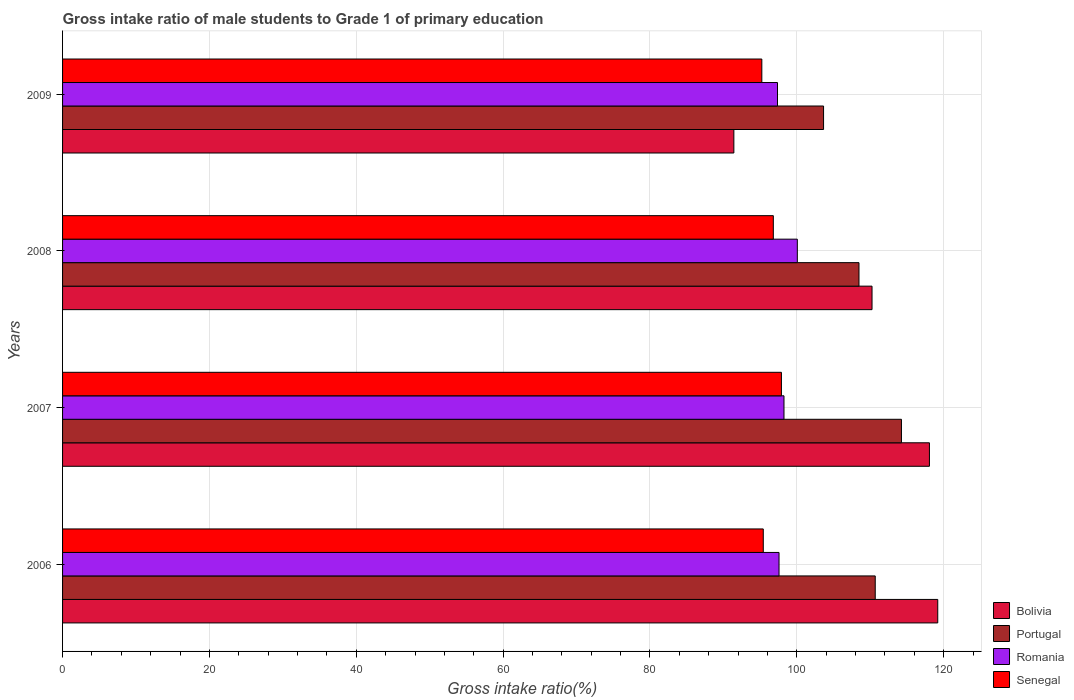How many bars are there on the 3rd tick from the top?
Your answer should be very brief. 4. What is the label of the 3rd group of bars from the top?
Offer a very short reply. 2007. In how many cases, is the number of bars for a given year not equal to the number of legend labels?
Provide a succinct answer. 0. What is the gross intake ratio in Romania in 2009?
Make the answer very short. 97.37. Across all years, what is the maximum gross intake ratio in Senegal?
Your answer should be compact. 97.9. Across all years, what is the minimum gross intake ratio in Portugal?
Keep it short and to the point. 103.64. In which year was the gross intake ratio in Portugal maximum?
Keep it short and to the point. 2007. What is the total gross intake ratio in Portugal in the graph?
Provide a succinct answer. 437.03. What is the difference between the gross intake ratio in Portugal in 2006 and that in 2007?
Offer a terse response. -3.57. What is the difference between the gross intake ratio in Romania in 2006 and the gross intake ratio in Portugal in 2007?
Your answer should be compact. -16.67. What is the average gross intake ratio in Senegal per year?
Keep it short and to the point. 96.34. In the year 2006, what is the difference between the gross intake ratio in Romania and gross intake ratio in Bolivia?
Provide a short and direct response. -21.62. In how many years, is the gross intake ratio in Portugal greater than 104 %?
Ensure brevity in your answer.  3. What is the ratio of the gross intake ratio in Bolivia in 2006 to that in 2009?
Offer a terse response. 1.3. What is the difference between the highest and the second highest gross intake ratio in Senegal?
Offer a terse response. 1.1. What is the difference between the highest and the lowest gross intake ratio in Portugal?
Offer a terse response. 10.61. What does the 3rd bar from the top in 2008 represents?
Give a very brief answer. Portugal. What does the 1st bar from the bottom in 2009 represents?
Ensure brevity in your answer.  Bolivia. Is it the case that in every year, the sum of the gross intake ratio in Romania and gross intake ratio in Senegal is greater than the gross intake ratio in Bolivia?
Offer a very short reply. Yes. Are the values on the major ticks of X-axis written in scientific E-notation?
Your answer should be compact. No. Does the graph contain grids?
Offer a very short reply. Yes. Where does the legend appear in the graph?
Ensure brevity in your answer.  Bottom right. How are the legend labels stacked?
Offer a very short reply. Vertical. What is the title of the graph?
Provide a succinct answer. Gross intake ratio of male students to Grade 1 of primary education. What is the label or title of the X-axis?
Make the answer very short. Gross intake ratio(%). What is the label or title of the Y-axis?
Make the answer very short. Years. What is the Gross intake ratio(%) of Bolivia in 2006?
Your answer should be very brief. 119.19. What is the Gross intake ratio(%) of Portugal in 2006?
Make the answer very short. 110.68. What is the Gross intake ratio(%) in Romania in 2006?
Provide a short and direct response. 97.58. What is the Gross intake ratio(%) of Senegal in 2006?
Your answer should be very brief. 95.43. What is the Gross intake ratio(%) of Bolivia in 2007?
Offer a terse response. 118.06. What is the Gross intake ratio(%) of Portugal in 2007?
Provide a short and direct response. 114.25. What is the Gross intake ratio(%) of Romania in 2007?
Keep it short and to the point. 98.25. What is the Gross intake ratio(%) in Senegal in 2007?
Ensure brevity in your answer.  97.9. What is the Gross intake ratio(%) of Bolivia in 2008?
Your answer should be compact. 110.24. What is the Gross intake ratio(%) of Portugal in 2008?
Your answer should be compact. 108.47. What is the Gross intake ratio(%) of Romania in 2008?
Ensure brevity in your answer.  100.07. What is the Gross intake ratio(%) in Senegal in 2008?
Keep it short and to the point. 96.8. What is the Gross intake ratio(%) of Bolivia in 2009?
Your answer should be very brief. 91.42. What is the Gross intake ratio(%) in Portugal in 2009?
Provide a succinct answer. 103.64. What is the Gross intake ratio(%) in Romania in 2009?
Keep it short and to the point. 97.37. What is the Gross intake ratio(%) of Senegal in 2009?
Offer a terse response. 95.23. Across all years, what is the maximum Gross intake ratio(%) of Bolivia?
Your answer should be compact. 119.19. Across all years, what is the maximum Gross intake ratio(%) of Portugal?
Make the answer very short. 114.25. Across all years, what is the maximum Gross intake ratio(%) in Romania?
Your answer should be very brief. 100.07. Across all years, what is the maximum Gross intake ratio(%) in Senegal?
Keep it short and to the point. 97.9. Across all years, what is the minimum Gross intake ratio(%) in Bolivia?
Offer a very short reply. 91.42. Across all years, what is the minimum Gross intake ratio(%) of Portugal?
Provide a short and direct response. 103.64. Across all years, what is the minimum Gross intake ratio(%) of Romania?
Keep it short and to the point. 97.37. Across all years, what is the minimum Gross intake ratio(%) in Senegal?
Your answer should be very brief. 95.23. What is the total Gross intake ratio(%) of Bolivia in the graph?
Your answer should be compact. 438.91. What is the total Gross intake ratio(%) of Portugal in the graph?
Your response must be concise. 437.03. What is the total Gross intake ratio(%) of Romania in the graph?
Offer a terse response. 393.26. What is the total Gross intake ratio(%) of Senegal in the graph?
Offer a terse response. 385.36. What is the difference between the Gross intake ratio(%) in Bolivia in 2006 and that in 2007?
Give a very brief answer. 1.13. What is the difference between the Gross intake ratio(%) of Portugal in 2006 and that in 2007?
Keep it short and to the point. -3.57. What is the difference between the Gross intake ratio(%) of Romania in 2006 and that in 2007?
Make the answer very short. -0.67. What is the difference between the Gross intake ratio(%) in Senegal in 2006 and that in 2007?
Make the answer very short. -2.47. What is the difference between the Gross intake ratio(%) of Bolivia in 2006 and that in 2008?
Keep it short and to the point. 8.95. What is the difference between the Gross intake ratio(%) in Portugal in 2006 and that in 2008?
Ensure brevity in your answer.  2.21. What is the difference between the Gross intake ratio(%) of Romania in 2006 and that in 2008?
Your answer should be very brief. -2.49. What is the difference between the Gross intake ratio(%) of Senegal in 2006 and that in 2008?
Ensure brevity in your answer.  -1.37. What is the difference between the Gross intake ratio(%) in Bolivia in 2006 and that in 2009?
Ensure brevity in your answer.  27.77. What is the difference between the Gross intake ratio(%) in Portugal in 2006 and that in 2009?
Provide a short and direct response. 7.04. What is the difference between the Gross intake ratio(%) in Romania in 2006 and that in 2009?
Make the answer very short. 0.21. What is the difference between the Gross intake ratio(%) in Senegal in 2006 and that in 2009?
Your answer should be very brief. 0.2. What is the difference between the Gross intake ratio(%) of Bolivia in 2007 and that in 2008?
Provide a short and direct response. 7.82. What is the difference between the Gross intake ratio(%) of Portugal in 2007 and that in 2008?
Your response must be concise. 5.78. What is the difference between the Gross intake ratio(%) in Romania in 2007 and that in 2008?
Offer a terse response. -1.82. What is the difference between the Gross intake ratio(%) of Senegal in 2007 and that in 2008?
Provide a short and direct response. 1.1. What is the difference between the Gross intake ratio(%) of Bolivia in 2007 and that in 2009?
Your response must be concise. 26.64. What is the difference between the Gross intake ratio(%) of Portugal in 2007 and that in 2009?
Your answer should be compact. 10.61. What is the difference between the Gross intake ratio(%) of Romania in 2007 and that in 2009?
Offer a very short reply. 0.88. What is the difference between the Gross intake ratio(%) in Senegal in 2007 and that in 2009?
Your answer should be compact. 2.67. What is the difference between the Gross intake ratio(%) of Bolivia in 2008 and that in 2009?
Offer a terse response. 18.82. What is the difference between the Gross intake ratio(%) of Portugal in 2008 and that in 2009?
Offer a terse response. 4.82. What is the difference between the Gross intake ratio(%) in Romania in 2008 and that in 2009?
Keep it short and to the point. 2.7. What is the difference between the Gross intake ratio(%) of Senegal in 2008 and that in 2009?
Offer a very short reply. 1.57. What is the difference between the Gross intake ratio(%) in Bolivia in 2006 and the Gross intake ratio(%) in Portugal in 2007?
Your response must be concise. 4.94. What is the difference between the Gross intake ratio(%) in Bolivia in 2006 and the Gross intake ratio(%) in Romania in 2007?
Provide a succinct answer. 20.94. What is the difference between the Gross intake ratio(%) of Bolivia in 2006 and the Gross intake ratio(%) of Senegal in 2007?
Provide a succinct answer. 21.29. What is the difference between the Gross intake ratio(%) of Portugal in 2006 and the Gross intake ratio(%) of Romania in 2007?
Offer a terse response. 12.43. What is the difference between the Gross intake ratio(%) of Portugal in 2006 and the Gross intake ratio(%) of Senegal in 2007?
Make the answer very short. 12.78. What is the difference between the Gross intake ratio(%) in Romania in 2006 and the Gross intake ratio(%) in Senegal in 2007?
Ensure brevity in your answer.  -0.33. What is the difference between the Gross intake ratio(%) in Bolivia in 2006 and the Gross intake ratio(%) in Portugal in 2008?
Your answer should be very brief. 10.73. What is the difference between the Gross intake ratio(%) in Bolivia in 2006 and the Gross intake ratio(%) in Romania in 2008?
Ensure brevity in your answer.  19.12. What is the difference between the Gross intake ratio(%) in Bolivia in 2006 and the Gross intake ratio(%) in Senegal in 2008?
Keep it short and to the point. 22.39. What is the difference between the Gross intake ratio(%) of Portugal in 2006 and the Gross intake ratio(%) of Romania in 2008?
Ensure brevity in your answer.  10.61. What is the difference between the Gross intake ratio(%) of Portugal in 2006 and the Gross intake ratio(%) of Senegal in 2008?
Offer a very short reply. 13.88. What is the difference between the Gross intake ratio(%) in Romania in 2006 and the Gross intake ratio(%) in Senegal in 2008?
Ensure brevity in your answer.  0.78. What is the difference between the Gross intake ratio(%) of Bolivia in 2006 and the Gross intake ratio(%) of Portugal in 2009?
Give a very brief answer. 15.55. What is the difference between the Gross intake ratio(%) in Bolivia in 2006 and the Gross intake ratio(%) in Romania in 2009?
Your response must be concise. 21.82. What is the difference between the Gross intake ratio(%) in Bolivia in 2006 and the Gross intake ratio(%) in Senegal in 2009?
Your answer should be very brief. 23.96. What is the difference between the Gross intake ratio(%) in Portugal in 2006 and the Gross intake ratio(%) in Romania in 2009?
Give a very brief answer. 13.31. What is the difference between the Gross intake ratio(%) of Portugal in 2006 and the Gross intake ratio(%) of Senegal in 2009?
Provide a short and direct response. 15.45. What is the difference between the Gross intake ratio(%) in Romania in 2006 and the Gross intake ratio(%) in Senegal in 2009?
Provide a succinct answer. 2.34. What is the difference between the Gross intake ratio(%) of Bolivia in 2007 and the Gross intake ratio(%) of Portugal in 2008?
Offer a terse response. 9.59. What is the difference between the Gross intake ratio(%) in Bolivia in 2007 and the Gross intake ratio(%) in Romania in 2008?
Provide a succinct answer. 17.99. What is the difference between the Gross intake ratio(%) in Bolivia in 2007 and the Gross intake ratio(%) in Senegal in 2008?
Offer a terse response. 21.26. What is the difference between the Gross intake ratio(%) in Portugal in 2007 and the Gross intake ratio(%) in Romania in 2008?
Ensure brevity in your answer.  14.18. What is the difference between the Gross intake ratio(%) in Portugal in 2007 and the Gross intake ratio(%) in Senegal in 2008?
Offer a very short reply. 17.45. What is the difference between the Gross intake ratio(%) in Romania in 2007 and the Gross intake ratio(%) in Senegal in 2008?
Ensure brevity in your answer.  1.45. What is the difference between the Gross intake ratio(%) in Bolivia in 2007 and the Gross intake ratio(%) in Portugal in 2009?
Provide a succinct answer. 14.42. What is the difference between the Gross intake ratio(%) in Bolivia in 2007 and the Gross intake ratio(%) in Romania in 2009?
Your answer should be compact. 20.69. What is the difference between the Gross intake ratio(%) of Bolivia in 2007 and the Gross intake ratio(%) of Senegal in 2009?
Provide a short and direct response. 22.83. What is the difference between the Gross intake ratio(%) of Portugal in 2007 and the Gross intake ratio(%) of Romania in 2009?
Offer a very short reply. 16.88. What is the difference between the Gross intake ratio(%) in Portugal in 2007 and the Gross intake ratio(%) in Senegal in 2009?
Give a very brief answer. 19.02. What is the difference between the Gross intake ratio(%) in Romania in 2007 and the Gross intake ratio(%) in Senegal in 2009?
Offer a terse response. 3.02. What is the difference between the Gross intake ratio(%) of Bolivia in 2008 and the Gross intake ratio(%) of Portugal in 2009?
Offer a terse response. 6.6. What is the difference between the Gross intake ratio(%) of Bolivia in 2008 and the Gross intake ratio(%) of Romania in 2009?
Offer a very short reply. 12.87. What is the difference between the Gross intake ratio(%) of Bolivia in 2008 and the Gross intake ratio(%) of Senegal in 2009?
Provide a succinct answer. 15.01. What is the difference between the Gross intake ratio(%) in Portugal in 2008 and the Gross intake ratio(%) in Romania in 2009?
Make the answer very short. 11.1. What is the difference between the Gross intake ratio(%) of Portugal in 2008 and the Gross intake ratio(%) of Senegal in 2009?
Keep it short and to the point. 13.23. What is the difference between the Gross intake ratio(%) in Romania in 2008 and the Gross intake ratio(%) in Senegal in 2009?
Give a very brief answer. 4.84. What is the average Gross intake ratio(%) in Bolivia per year?
Provide a short and direct response. 109.73. What is the average Gross intake ratio(%) of Portugal per year?
Provide a succinct answer. 109.26. What is the average Gross intake ratio(%) of Romania per year?
Your answer should be very brief. 98.32. What is the average Gross intake ratio(%) of Senegal per year?
Your response must be concise. 96.34. In the year 2006, what is the difference between the Gross intake ratio(%) in Bolivia and Gross intake ratio(%) in Portugal?
Provide a succinct answer. 8.51. In the year 2006, what is the difference between the Gross intake ratio(%) of Bolivia and Gross intake ratio(%) of Romania?
Provide a succinct answer. 21.62. In the year 2006, what is the difference between the Gross intake ratio(%) of Bolivia and Gross intake ratio(%) of Senegal?
Ensure brevity in your answer.  23.76. In the year 2006, what is the difference between the Gross intake ratio(%) in Portugal and Gross intake ratio(%) in Romania?
Your response must be concise. 13.1. In the year 2006, what is the difference between the Gross intake ratio(%) of Portugal and Gross intake ratio(%) of Senegal?
Keep it short and to the point. 15.25. In the year 2006, what is the difference between the Gross intake ratio(%) in Romania and Gross intake ratio(%) in Senegal?
Give a very brief answer. 2.15. In the year 2007, what is the difference between the Gross intake ratio(%) in Bolivia and Gross intake ratio(%) in Portugal?
Give a very brief answer. 3.81. In the year 2007, what is the difference between the Gross intake ratio(%) of Bolivia and Gross intake ratio(%) of Romania?
Your response must be concise. 19.81. In the year 2007, what is the difference between the Gross intake ratio(%) in Bolivia and Gross intake ratio(%) in Senegal?
Ensure brevity in your answer.  20.16. In the year 2007, what is the difference between the Gross intake ratio(%) of Portugal and Gross intake ratio(%) of Romania?
Offer a terse response. 16. In the year 2007, what is the difference between the Gross intake ratio(%) of Portugal and Gross intake ratio(%) of Senegal?
Offer a very short reply. 16.35. In the year 2007, what is the difference between the Gross intake ratio(%) in Romania and Gross intake ratio(%) in Senegal?
Your response must be concise. 0.35. In the year 2008, what is the difference between the Gross intake ratio(%) of Bolivia and Gross intake ratio(%) of Portugal?
Provide a short and direct response. 1.78. In the year 2008, what is the difference between the Gross intake ratio(%) in Bolivia and Gross intake ratio(%) in Romania?
Give a very brief answer. 10.17. In the year 2008, what is the difference between the Gross intake ratio(%) of Bolivia and Gross intake ratio(%) of Senegal?
Your answer should be compact. 13.44. In the year 2008, what is the difference between the Gross intake ratio(%) in Portugal and Gross intake ratio(%) in Romania?
Ensure brevity in your answer.  8.4. In the year 2008, what is the difference between the Gross intake ratio(%) of Portugal and Gross intake ratio(%) of Senegal?
Ensure brevity in your answer.  11.67. In the year 2008, what is the difference between the Gross intake ratio(%) in Romania and Gross intake ratio(%) in Senegal?
Make the answer very short. 3.27. In the year 2009, what is the difference between the Gross intake ratio(%) in Bolivia and Gross intake ratio(%) in Portugal?
Give a very brief answer. -12.22. In the year 2009, what is the difference between the Gross intake ratio(%) of Bolivia and Gross intake ratio(%) of Romania?
Provide a short and direct response. -5.94. In the year 2009, what is the difference between the Gross intake ratio(%) in Bolivia and Gross intake ratio(%) in Senegal?
Your answer should be compact. -3.81. In the year 2009, what is the difference between the Gross intake ratio(%) in Portugal and Gross intake ratio(%) in Romania?
Offer a very short reply. 6.27. In the year 2009, what is the difference between the Gross intake ratio(%) of Portugal and Gross intake ratio(%) of Senegal?
Keep it short and to the point. 8.41. In the year 2009, what is the difference between the Gross intake ratio(%) of Romania and Gross intake ratio(%) of Senegal?
Your response must be concise. 2.13. What is the ratio of the Gross intake ratio(%) in Bolivia in 2006 to that in 2007?
Offer a terse response. 1.01. What is the ratio of the Gross intake ratio(%) of Portugal in 2006 to that in 2007?
Keep it short and to the point. 0.97. What is the ratio of the Gross intake ratio(%) in Romania in 2006 to that in 2007?
Provide a succinct answer. 0.99. What is the ratio of the Gross intake ratio(%) of Senegal in 2006 to that in 2007?
Your answer should be very brief. 0.97. What is the ratio of the Gross intake ratio(%) of Bolivia in 2006 to that in 2008?
Your answer should be compact. 1.08. What is the ratio of the Gross intake ratio(%) in Portugal in 2006 to that in 2008?
Provide a short and direct response. 1.02. What is the ratio of the Gross intake ratio(%) in Romania in 2006 to that in 2008?
Your answer should be compact. 0.98. What is the ratio of the Gross intake ratio(%) in Senegal in 2006 to that in 2008?
Provide a short and direct response. 0.99. What is the ratio of the Gross intake ratio(%) in Bolivia in 2006 to that in 2009?
Your answer should be very brief. 1.3. What is the ratio of the Gross intake ratio(%) in Portugal in 2006 to that in 2009?
Provide a succinct answer. 1.07. What is the ratio of the Gross intake ratio(%) in Romania in 2006 to that in 2009?
Your response must be concise. 1. What is the ratio of the Gross intake ratio(%) of Senegal in 2006 to that in 2009?
Offer a terse response. 1. What is the ratio of the Gross intake ratio(%) in Bolivia in 2007 to that in 2008?
Make the answer very short. 1.07. What is the ratio of the Gross intake ratio(%) in Portugal in 2007 to that in 2008?
Provide a succinct answer. 1.05. What is the ratio of the Gross intake ratio(%) in Romania in 2007 to that in 2008?
Your answer should be very brief. 0.98. What is the ratio of the Gross intake ratio(%) in Senegal in 2007 to that in 2008?
Your response must be concise. 1.01. What is the ratio of the Gross intake ratio(%) of Bolivia in 2007 to that in 2009?
Keep it short and to the point. 1.29. What is the ratio of the Gross intake ratio(%) of Portugal in 2007 to that in 2009?
Offer a very short reply. 1.1. What is the ratio of the Gross intake ratio(%) of Romania in 2007 to that in 2009?
Provide a succinct answer. 1.01. What is the ratio of the Gross intake ratio(%) in Senegal in 2007 to that in 2009?
Your answer should be compact. 1.03. What is the ratio of the Gross intake ratio(%) in Bolivia in 2008 to that in 2009?
Your response must be concise. 1.21. What is the ratio of the Gross intake ratio(%) in Portugal in 2008 to that in 2009?
Provide a short and direct response. 1.05. What is the ratio of the Gross intake ratio(%) of Romania in 2008 to that in 2009?
Give a very brief answer. 1.03. What is the ratio of the Gross intake ratio(%) of Senegal in 2008 to that in 2009?
Give a very brief answer. 1.02. What is the difference between the highest and the second highest Gross intake ratio(%) of Bolivia?
Give a very brief answer. 1.13. What is the difference between the highest and the second highest Gross intake ratio(%) of Portugal?
Provide a short and direct response. 3.57. What is the difference between the highest and the second highest Gross intake ratio(%) of Romania?
Give a very brief answer. 1.82. What is the difference between the highest and the second highest Gross intake ratio(%) in Senegal?
Your answer should be compact. 1.1. What is the difference between the highest and the lowest Gross intake ratio(%) of Bolivia?
Offer a terse response. 27.77. What is the difference between the highest and the lowest Gross intake ratio(%) of Portugal?
Offer a very short reply. 10.61. What is the difference between the highest and the lowest Gross intake ratio(%) in Romania?
Your answer should be compact. 2.7. What is the difference between the highest and the lowest Gross intake ratio(%) of Senegal?
Provide a succinct answer. 2.67. 